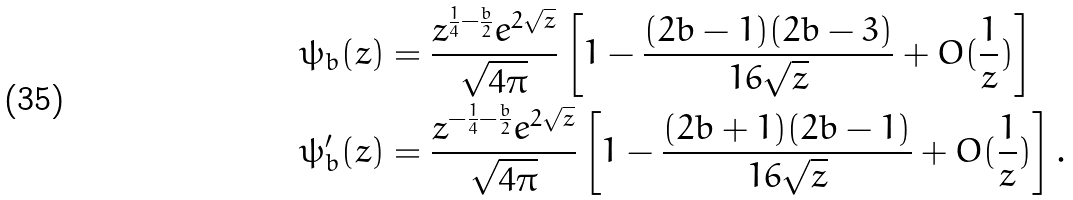<formula> <loc_0><loc_0><loc_500><loc_500>\psi _ { b } ( z ) & = \frac { z ^ { \frac { 1 } { 4 } - \frac { b } { 2 } } e ^ { 2 \sqrt { z } } } { \sqrt { 4 \pi } } \left [ 1 - \frac { ( 2 b - 1 ) ( 2 b - 3 ) } { 1 6 \sqrt { z } } + O ( \frac { 1 } { z } ) \right ] \\ \psi _ { b } ^ { \prime } ( z ) & = \frac { z ^ { - \frac { 1 } { 4 } - \frac { b } { 2 } } e ^ { 2 \sqrt { z } } } { \sqrt { 4 \pi } } \left [ 1 - \frac { ( 2 b + 1 ) ( 2 b - 1 ) } { 1 6 \sqrt { z } } + O ( \frac { 1 } { z } ) \right ] .</formula> 